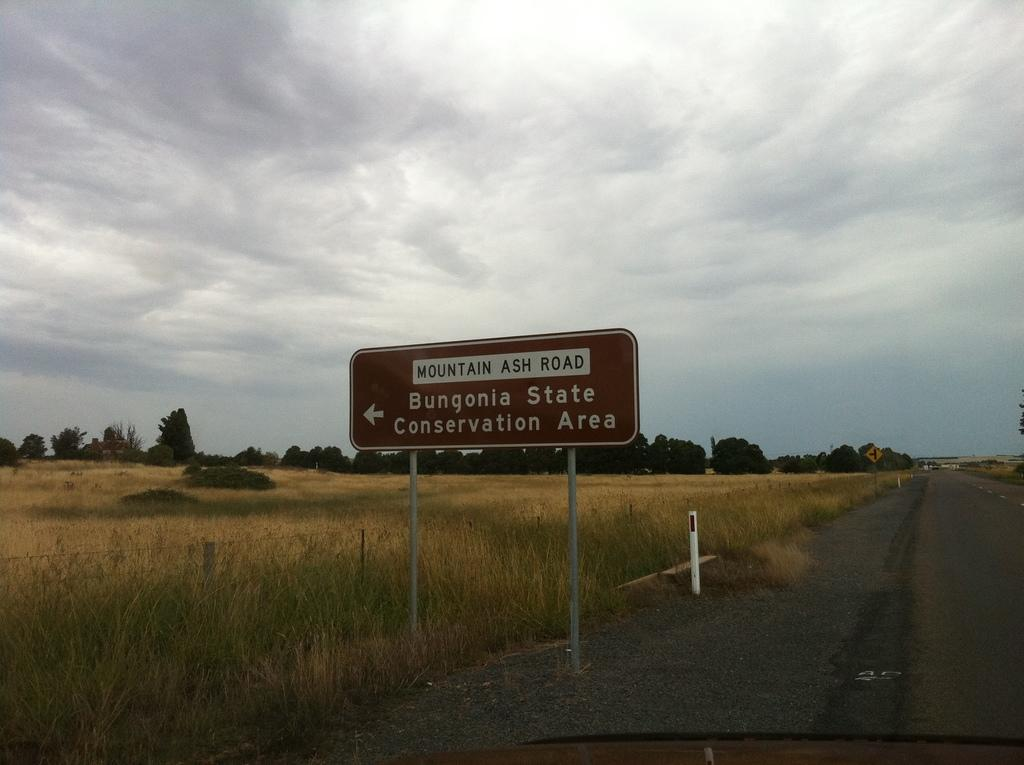<image>
Describe the image concisely. Brown sign pointing to Bungonia State on a cloudy day. 